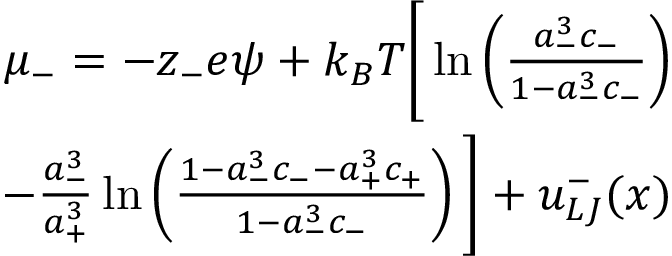Convert formula to latex. <formula><loc_0><loc_0><loc_500><loc_500>\begin{array} { r } { \mu _ { - } = - z _ { - } e \psi + k _ { B } T \left [ \ln \left ( { \frac { a _ { - } ^ { 3 } c _ { - } } { 1 - a _ { - } ^ { 3 } c _ { - } } } \right ) } \\ { - \frac { a _ { - } ^ { 3 } } { a _ { + } ^ { 3 } } \ln \left ( { \frac { 1 - a _ { - } ^ { 3 } c _ { - } - a _ { + } ^ { 3 } c _ { + } } { 1 - a _ { - } ^ { 3 } c _ { - } } } \right ) \right ] + u _ { L J } ^ { - } ( x ) } \end{array}</formula> 